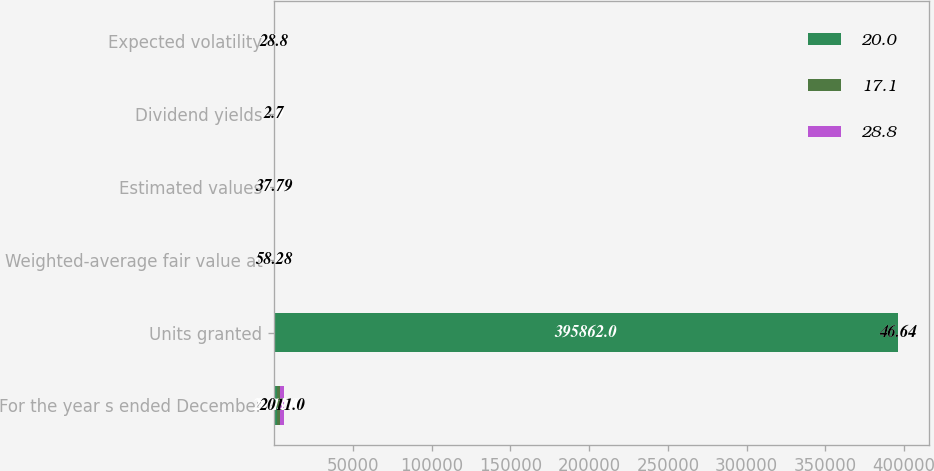Convert chart. <chart><loc_0><loc_0><loc_500><loc_500><stacked_bar_chart><ecel><fcel>For the year s ended December<fcel>Units granted<fcel>Weighted-average fair value at<fcel>Estimated values<fcel>Dividend yields<fcel>Expected volatility<nl><fcel>20<fcel>2013<fcel>395862<fcel>88.49<fcel>55.49<fcel>2<fcel>17.1<nl><fcel>17.1<fcel>2012<fcel>46.64<fcel>64.99<fcel>35.62<fcel>2.5<fcel>20<nl><fcel>28.8<fcel>2011<fcel>46.64<fcel>58.28<fcel>37.79<fcel>2.7<fcel>28.8<nl></chart> 